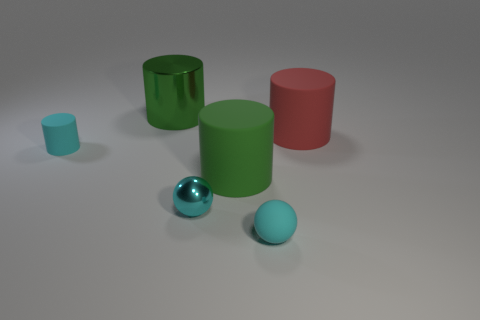Can you describe the size comparison between the green and red cylinders? Certainly! The green cylinder is taller and has a larger diameter compared to the red cylinder, indicating its larger overall volume. 